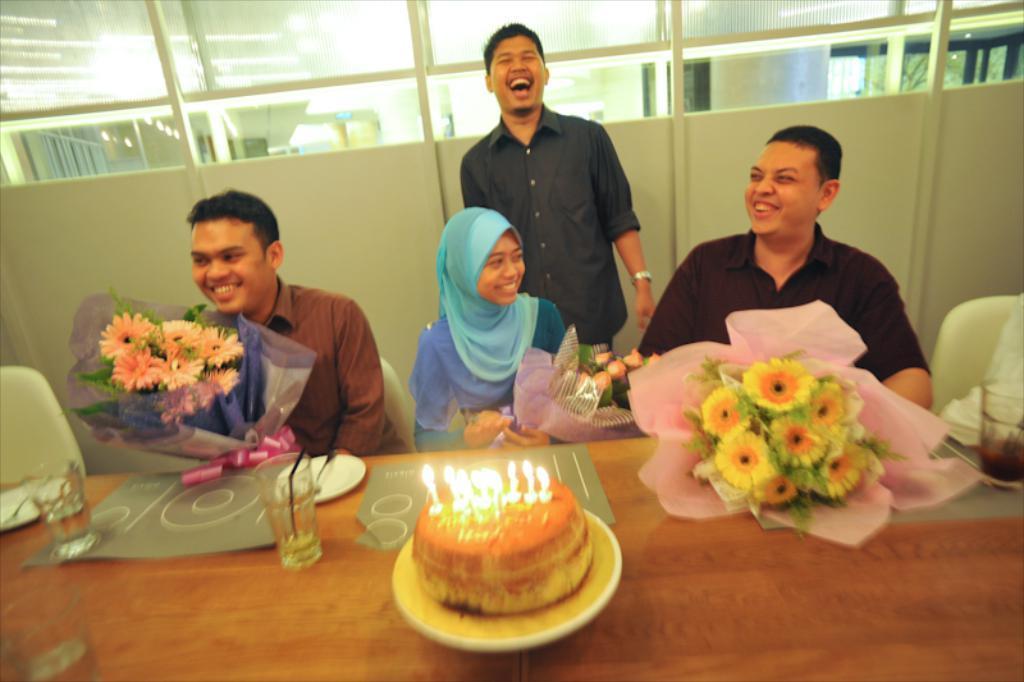How would you summarize this image in a sentence or two? There are three people sitting on the chairs and smiling. Here is another person standing and smiling. This is the table with a cake,glass,flower bouquet. At background this looks like a glass doors. 